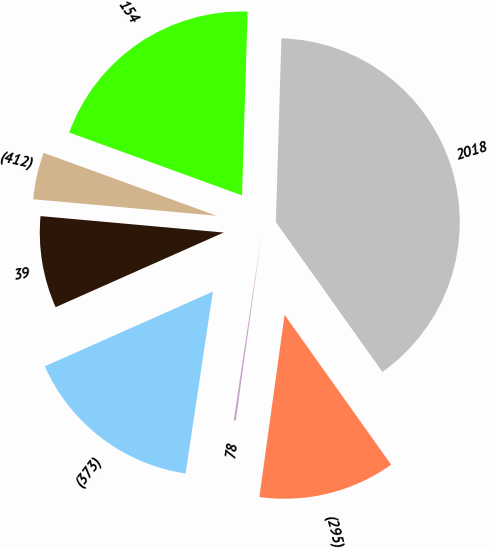Convert chart. <chart><loc_0><loc_0><loc_500><loc_500><pie_chart><fcel>2018<fcel>154<fcel>(412)<fcel>39<fcel>(373)<fcel>78<fcel>(295)<nl><fcel>39.68%<fcel>19.93%<fcel>4.13%<fcel>8.08%<fcel>15.98%<fcel>0.18%<fcel>12.03%<nl></chart> 